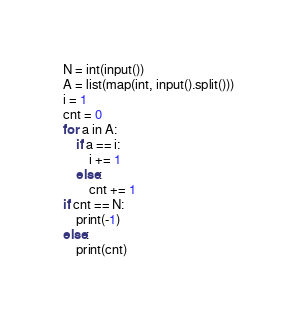Convert code to text. <code><loc_0><loc_0><loc_500><loc_500><_Python_>N = int(input())
A = list(map(int, input().split()))
i = 1
cnt = 0
for a in A:
    if a == i:
        i += 1
    else:
        cnt += 1
if cnt == N:
    print(-1)
else:
    print(cnt)</code> 